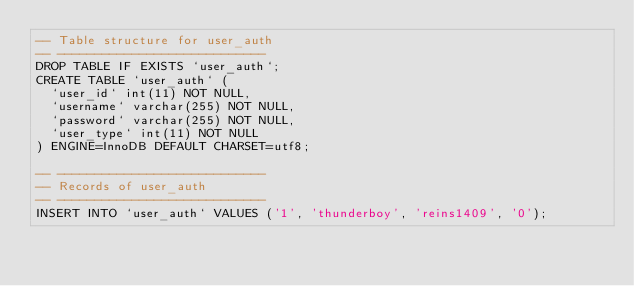Convert code to text. <code><loc_0><loc_0><loc_500><loc_500><_SQL_>-- Table structure for user_auth
-- ----------------------------
DROP TABLE IF EXISTS `user_auth`;
CREATE TABLE `user_auth` (
  `user_id` int(11) NOT NULL,
  `username` varchar(255) NOT NULL,
  `password` varchar(255) NOT NULL,
  `user_type` int(11) NOT NULL
) ENGINE=InnoDB DEFAULT CHARSET=utf8;

-- ----------------------------
-- Records of user_auth
-- ----------------------------
INSERT INTO `user_auth` VALUES ('1', 'thunderboy', 'reins1409', '0');
</code> 